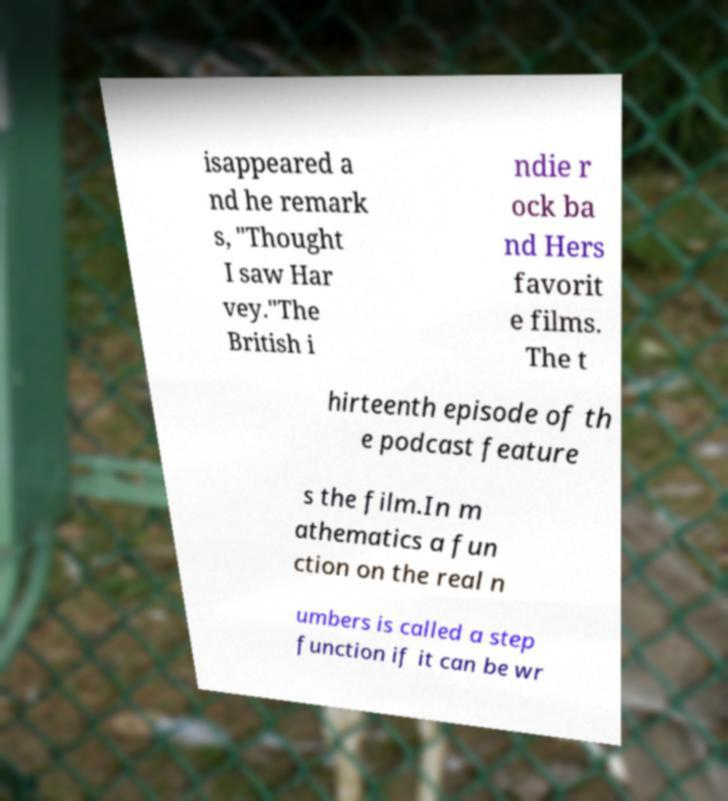There's text embedded in this image that I need extracted. Can you transcribe it verbatim? isappeared a nd he remark s, "Thought I saw Har vey."The British i ndie r ock ba nd Hers favorit e films. The t hirteenth episode of th e podcast feature s the film.In m athematics a fun ction on the real n umbers is called a step function if it can be wr 